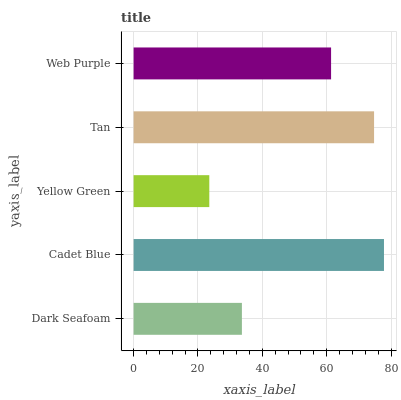Is Yellow Green the minimum?
Answer yes or no. Yes. Is Cadet Blue the maximum?
Answer yes or no. Yes. Is Cadet Blue the minimum?
Answer yes or no. No. Is Yellow Green the maximum?
Answer yes or no. No. Is Cadet Blue greater than Yellow Green?
Answer yes or no. Yes. Is Yellow Green less than Cadet Blue?
Answer yes or no. Yes. Is Yellow Green greater than Cadet Blue?
Answer yes or no. No. Is Cadet Blue less than Yellow Green?
Answer yes or no. No. Is Web Purple the high median?
Answer yes or no. Yes. Is Web Purple the low median?
Answer yes or no. Yes. Is Dark Seafoam the high median?
Answer yes or no. No. Is Dark Seafoam the low median?
Answer yes or no. No. 